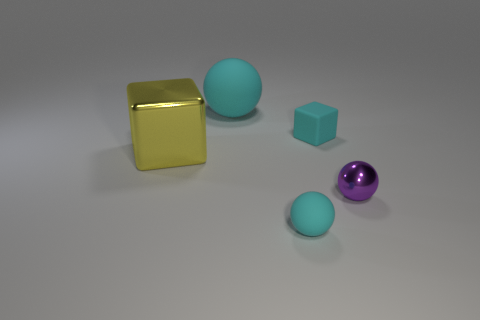Do the small cyan object that is behind the purple metal object and the thing behind the small cyan rubber block have the same shape?
Your answer should be compact. No. There is another object that is made of the same material as the large yellow object; what shape is it?
Provide a succinct answer. Sphere. Are there the same number of tiny cyan rubber cubes left of the big cyan matte object and tiny cyan spheres?
Offer a very short reply. No. Are the big object in front of the cyan block and the cyan object in front of the tiny cyan cube made of the same material?
Keep it short and to the point. No. The tiny cyan object behind the rubber sphere in front of the purple thing is what shape?
Give a very brief answer. Cube. There is a tiny block that is made of the same material as the large ball; what color is it?
Provide a succinct answer. Cyan. Is the color of the big matte thing the same as the big metallic cube?
Give a very brief answer. No. There is a matte thing that is the same size as the metallic block; what is its shape?
Provide a succinct answer. Sphere. How big is the purple metallic ball?
Provide a succinct answer. Small. There is a matte sphere that is behind the matte block; is it the same size as the matte sphere in front of the big yellow metal cube?
Provide a short and direct response. No. 